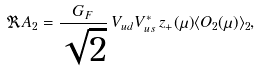<formula> <loc_0><loc_0><loc_500><loc_500>\Re A _ { 2 } = \frac { G _ { F } } { \sqrt { 2 } } \, V _ { u d } V _ { u s } ^ { * } \, z _ { + } ( \mu ) \langle O _ { 2 } ( \mu ) \rangle _ { 2 } ,</formula> 